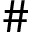<formula> <loc_0><loc_0><loc_500><loc_500>\#</formula> 